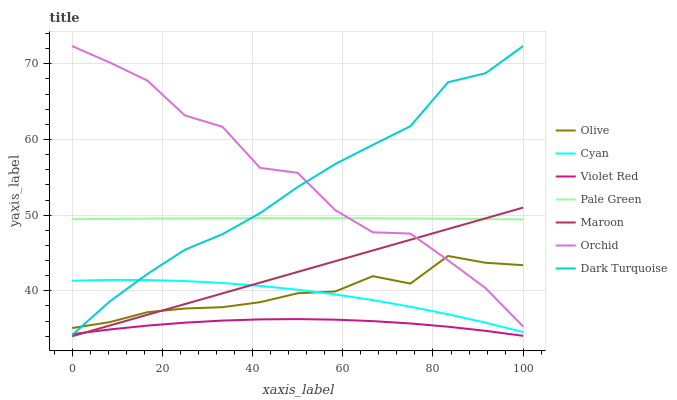Does Dark Turquoise have the minimum area under the curve?
Answer yes or no. No. Does Dark Turquoise have the maximum area under the curve?
Answer yes or no. No. Is Dark Turquoise the smoothest?
Answer yes or no. No. Is Dark Turquoise the roughest?
Answer yes or no. No. Does Dark Turquoise have the lowest value?
Answer yes or no. No. Does Maroon have the highest value?
Answer yes or no. No. Is Violet Red less than Pale Green?
Answer yes or no. Yes. Is Cyan greater than Violet Red?
Answer yes or no. Yes. Does Violet Red intersect Pale Green?
Answer yes or no. No. 